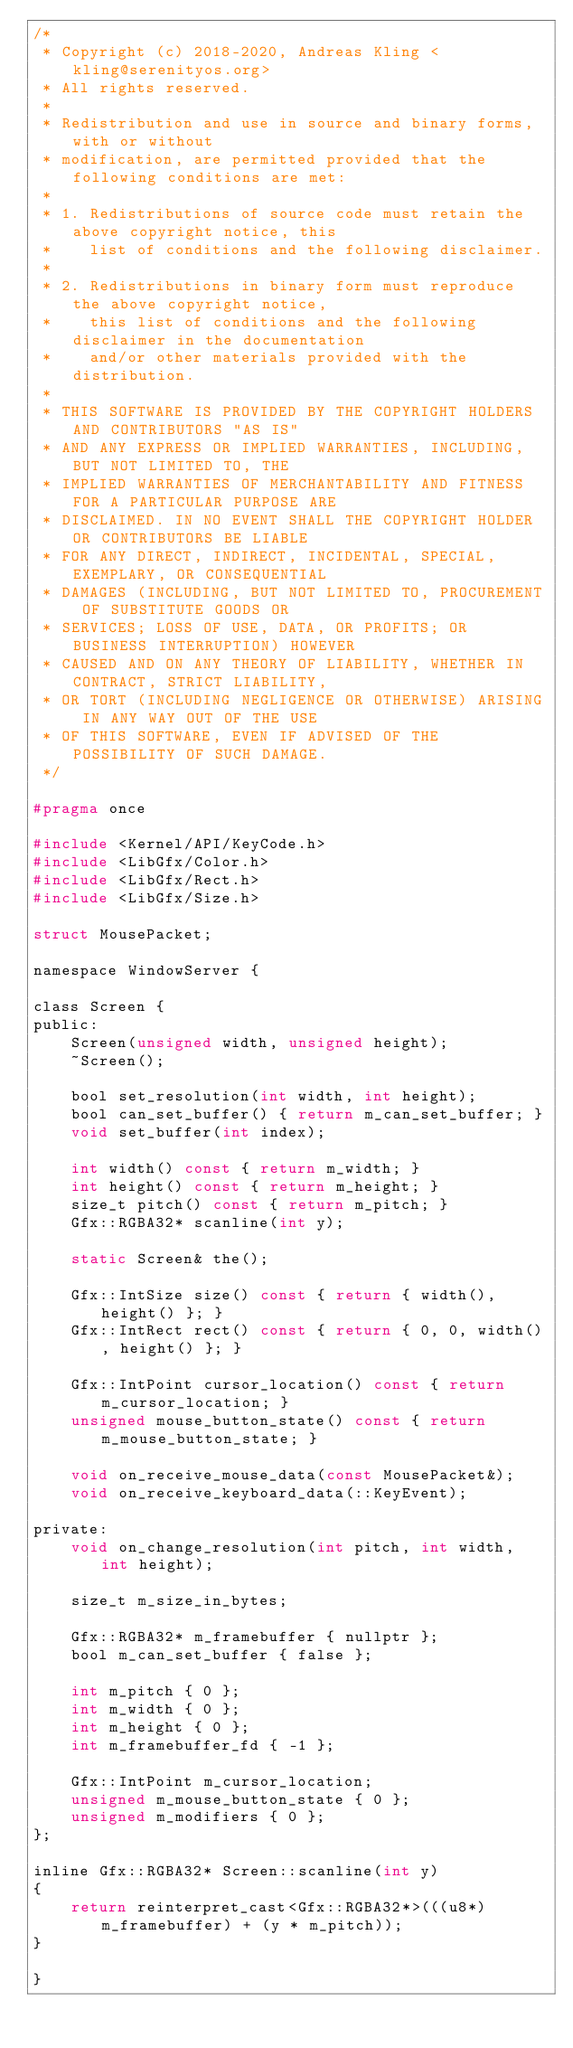Convert code to text. <code><loc_0><loc_0><loc_500><loc_500><_C_>/*
 * Copyright (c) 2018-2020, Andreas Kling <kling@serenityos.org>
 * All rights reserved.
 *
 * Redistribution and use in source and binary forms, with or without
 * modification, are permitted provided that the following conditions are met:
 *
 * 1. Redistributions of source code must retain the above copyright notice, this
 *    list of conditions and the following disclaimer.
 *
 * 2. Redistributions in binary form must reproduce the above copyright notice,
 *    this list of conditions and the following disclaimer in the documentation
 *    and/or other materials provided with the distribution.
 *
 * THIS SOFTWARE IS PROVIDED BY THE COPYRIGHT HOLDERS AND CONTRIBUTORS "AS IS"
 * AND ANY EXPRESS OR IMPLIED WARRANTIES, INCLUDING, BUT NOT LIMITED TO, THE
 * IMPLIED WARRANTIES OF MERCHANTABILITY AND FITNESS FOR A PARTICULAR PURPOSE ARE
 * DISCLAIMED. IN NO EVENT SHALL THE COPYRIGHT HOLDER OR CONTRIBUTORS BE LIABLE
 * FOR ANY DIRECT, INDIRECT, INCIDENTAL, SPECIAL, EXEMPLARY, OR CONSEQUENTIAL
 * DAMAGES (INCLUDING, BUT NOT LIMITED TO, PROCUREMENT OF SUBSTITUTE GOODS OR
 * SERVICES; LOSS OF USE, DATA, OR PROFITS; OR BUSINESS INTERRUPTION) HOWEVER
 * CAUSED AND ON ANY THEORY OF LIABILITY, WHETHER IN CONTRACT, STRICT LIABILITY,
 * OR TORT (INCLUDING NEGLIGENCE OR OTHERWISE) ARISING IN ANY WAY OUT OF THE USE
 * OF THIS SOFTWARE, EVEN IF ADVISED OF THE POSSIBILITY OF SUCH DAMAGE.
 */

#pragma once

#include <Kernel/API/KeyCode.h>
#include <LibGfx/Color.h>
#include <LibGfx/Rect.h>
#include <LibGfx/Size.h>

struct MousePacket;

namespace WindowServer {

class Screen {
public:
    Screen(unsigned width, unsigned height);
    ~Screen();

    bool set_resolution(int width, int height);
    bool can_set_buffer() { return m_can_set_buffer; }
    void set_buffer(int index);

    int width() const { return m_width; }
    int height() const { return m_height; }
    size_t pitch() const { return m_pitch; }
    Gfx::RGBA32* scanline(int y);

    static Screen& the();

    Gfx::IntSize size() const { return { width(), height() }; }
    Gfx::IntRect rect() const { return { 0, 0, width(), height() }; }

    Gfx::IntPoint cursor_location() const { return m_cursor_location; }
    unsigned mouse_button_state() const { return m_mouse_button_state; }

    void on_receive_mouse_data(const MousePacket&);
    void on_receive_keyboard_data(::KeyEvent);

private:
    void on_change_resolution(int pitch, int width, int height);

    size_t m_size_in_bytes;

    Gfx::RGBA32* m_framebuffer { nullptr };
    bool m_can_set_buffer { false };

    int m_pitch { 0 };
    int m_width { 0 };
    int m_height { 0 };
    int m_framebuffer_fd { -1 };

    Gfx::IntPoint m_cursor_location;
    unsigned m_mouse_button_state { 0 };
    unsigned m_modifiers { 0 };
};

inline Gfx::RGBA32* Screen::scanline(int y)
{
    return reinterpret_cast<Gfx::RGBA32*>(((u8*)m_framebuffer) + (y * m_pitch));
}

}
</code> 